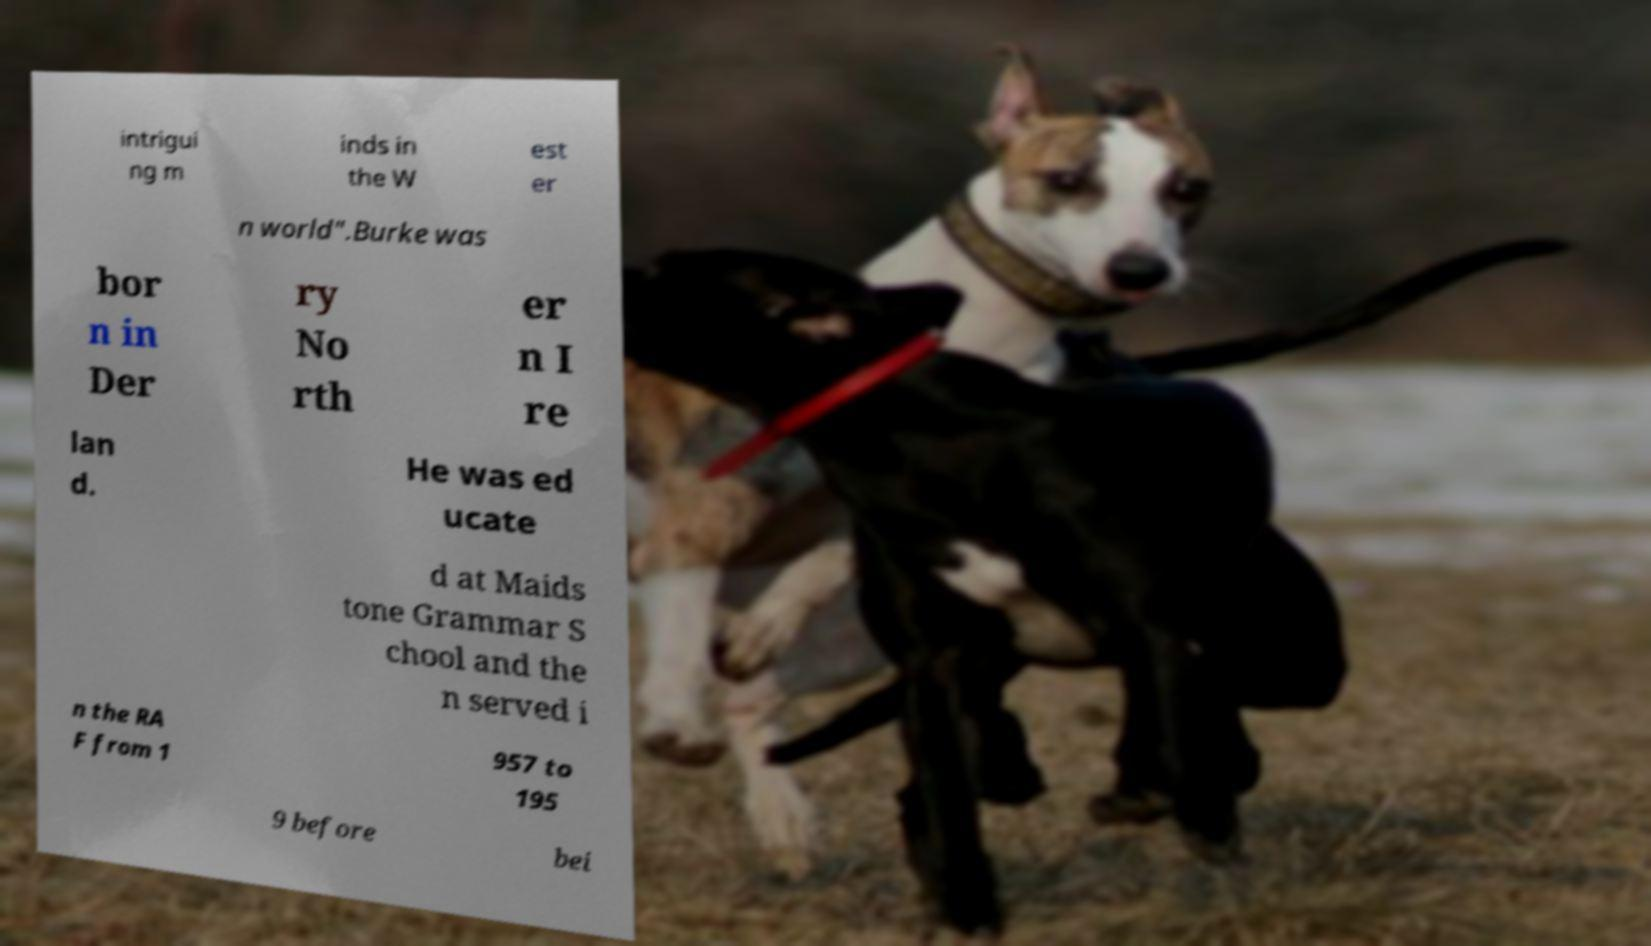Please read and relay the text visible in this image. What does it say? intrigui ng m inds in the W est er n world".Burke was bor n in Der ry No rth er n I re lan d. He was ed ucate d at Maids tone Grammar S chool and the n served i n the RA F from 1 957 to 195 9 before bei 